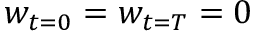<formula> <loc_0><loc_0><loc_500><loc_500>w _ { t = 0 } = w _ { t = T } = 0</formula> 